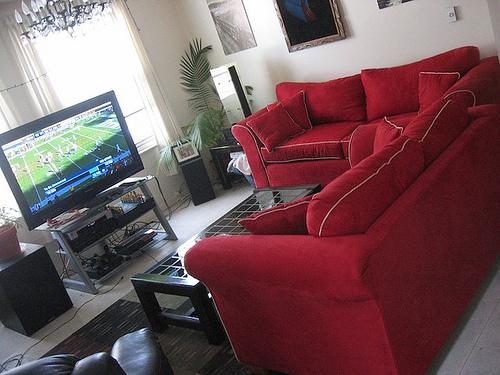What game is on television?
Concise answer only. Football. Are there any people sitting on the couch?
Quick response, please. No. What color is the couch?
Keep it brief. Red. 